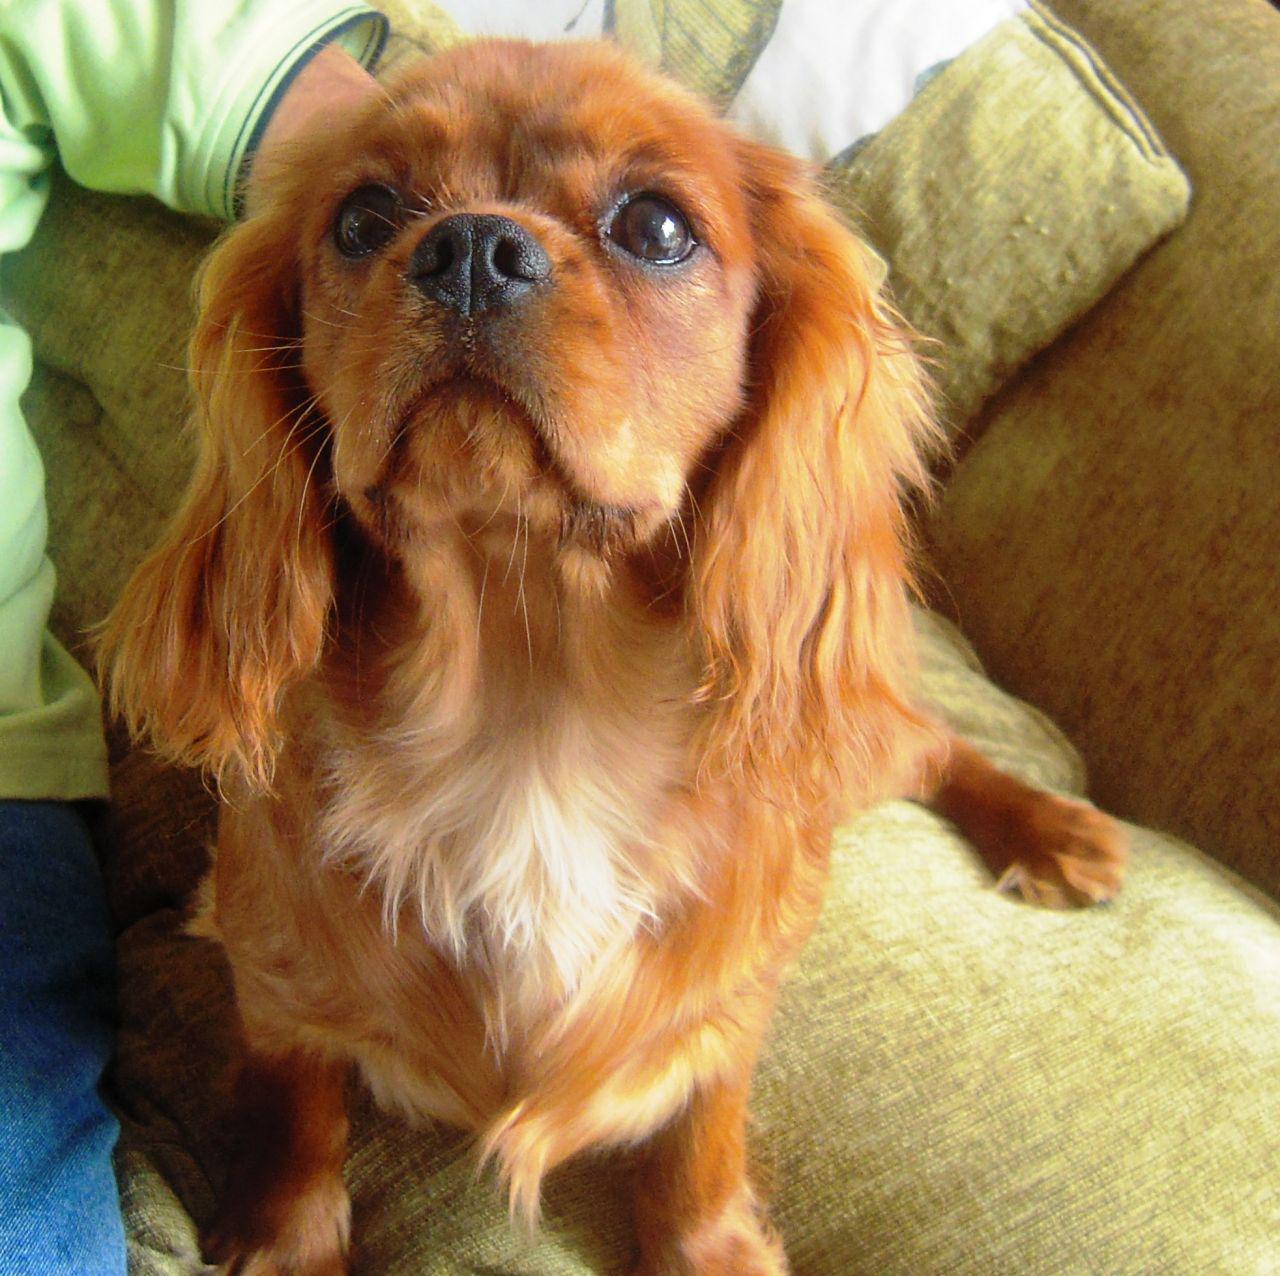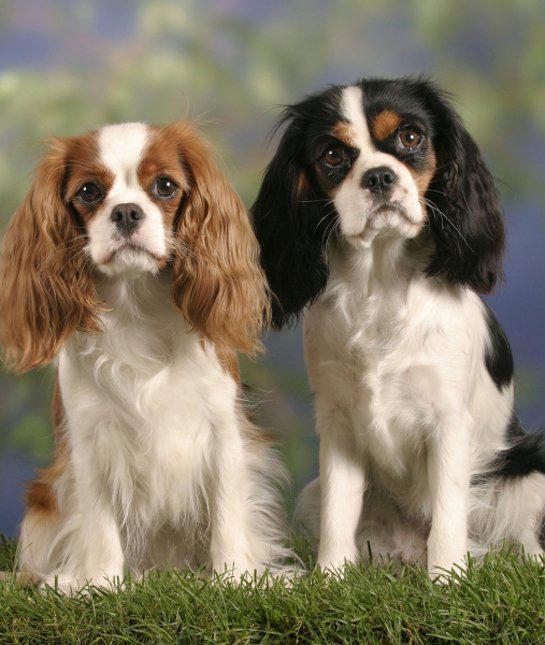The first image is the image on the left, the second image is the image on the right. Assess this claim about the two images: "An image shows just one dog on green grass.". Correct or not? Answer yes or no. No. The first image is the image on the left, the second image is the image on the right. Considering the images on both sides, is "There is a single dog on grass in one of the images." valid? Answer yes or no. No. The first image is the image on the left, the second image is the image on the right. Considering the images on both sides, is "An image shows one spaniel posed on green grass." valid? Answer yes or no. No. The first image is the image on the left, the second image is the image on the right. For the images shown, is this caption "One of the images shows one dog on grass." true? Answer yes or no. No. 